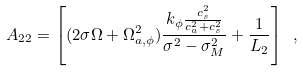Convert formula to latex. <formula><loc_0><loc_0><loc_500><loc_500>A _ { 2 2 } = \left [ ( 2 \sigma \Omega + \Omega _ { a , \phi } ^ { 2 } ) \frac { k _ { \phi } \frac { c _ { s } ^ { 2 } } { c _ { a } ^ { 2 } + c _ { s } ^ { 2 } } } { \sigma ^ { 2 } - \sigma _ { M } ^ { 2 } } + \frac { 1 } { L _ { 2 } } \right ] \ ,</formula> 